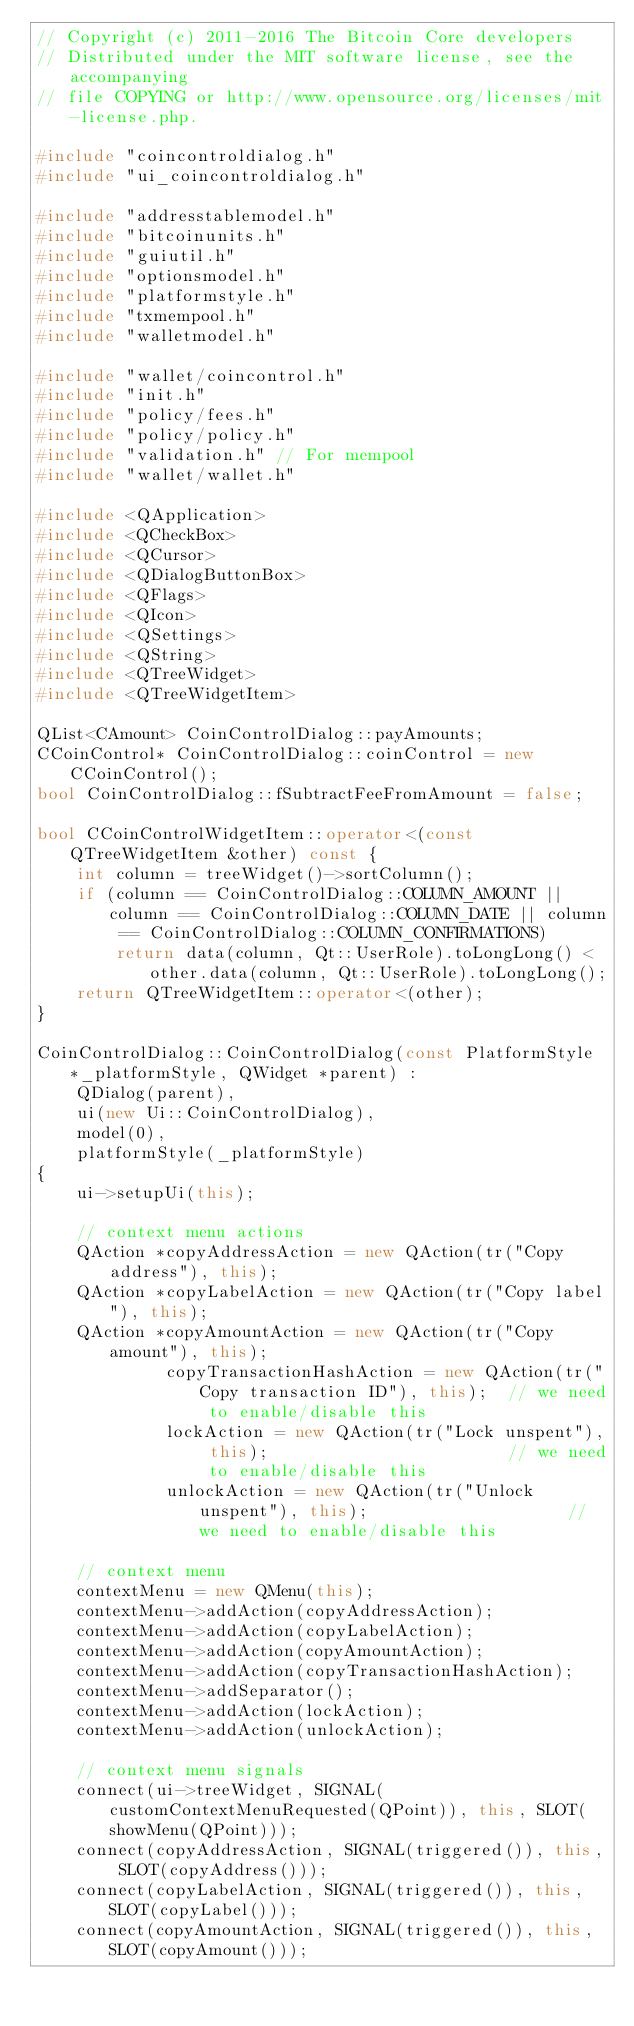Convert code to text. <code><loc_0><loc_0><loc_500><loc_500><_C++_>// Copyright (c) 2011-2016 The Bitcoin Core developers
// Distributed under the MIT software license, see the accompanying
// file COPYING or http://www.opensource.org/licenses/mit-license.php.

#include "coincontroldialog.h"
#include "ui_coincontroldialog.h"

#include "addresstablemodel.h"
#include "bitcoinunits.h"
#include "guiutil.h"
#include "optionsmodel.h"
#include "platformstyle.h"
#include "txmempool.h"
#include "walletmodel.h"

#include "wallet/coincontrol.h"
#include "init.h"
#include "policy/fees.h"
#include "policy/policy.h"
#include "validation.h" // For mempool
#include "wallet/wallet.h"

#include <QApplication>
#include <QCheckBox>
#include <QCursor>
#include <QDialogButtonBox>
#include <QFlags>
#include <QIcon>
#include <QSettings>
#include <QString>
#include <QTreeWidget>
#include <QTreeWidgetItem>

QList<CAmount> CoinControlDialog::payAmounts;
CCoinControl* CoinControlDialog::coinControl = new CCoinControl();
bool CoinControlDialog::fSubtractFeeFromAmount = false;

bool CCoinControlWidgetItem::operator<(const QTreeWidgetItem &other) const {
    int column = treeWidget()->sortColumn();
    if (column == CoinControlDialog::COLUMN_AMOUNT || column == CoinControlDialog::COLUMN_DATE || column == CoinControlDialog::COLUMN_CONFIRMATIONS)
        return data(column, Qt::UserRole).toLongLong() < other.data(column, Qt::UserRole).toLongLong();
    return QTreeWidgetItem::operator<(other);
}

CoinControlDialog::CoinControlDialog(const PlatformStyle *_platformStyle, QWidget *parent) :
    QDialog(parent),
    ui(new Ui::CoinControlDialog),
    model(0),
    platformStyle(_platformStyle)
{
    ui->setupUi(this);

    // context menu actions
    QAction *copyAddressAction = new QAction(tr("Copy address"), this);
    QAction *copyLabelAction = new QAction(tr("Copy label"), this);
    QAction *copyAmountAction = new QAction(tr("Copy amount"), this);
             copyTransactionHashAction = new QAction(tr("Copy transaction ID"), this);  // we need to enable/disable this
             lockAction = new QAction(tr("Lock unspent"), this);                        // we need to enable/disable this
             unlockAction = new QAction(tr("Unlock unspent"), this);                    // we need to enable/disable this

    // context menu
    contextMenu = new QMenu(this);
    contextMenu->addAction(copyAddressAction);
    contextMenu->addAction(copyLabelAction);
    contextMenu->addAction(copyAmountAction);
    contextMenu->addAction(copyTransactionHashAction);
    contextMenu->addSeparator();
    contextMenu->addAction(lockAction);
    contextMenu->addAction(unlockAction);

    // context menu signals
    connect(ui->treeWidget, SIGNAL(customContextMenuRequested(QPoint)), this, SLOT(showMenu(QPoint)));
    connect(copyAddressAction, SIGNAL(triggered()), this, SLOT(copyAddress()));
    connect(copyLabelAction, SIGNAL(triggered()), this, SLOT(copyLabel()));
    connect(copyAmountAction, SIGNAL(triggered()), this, SLOT(copyAmount()));</code> 